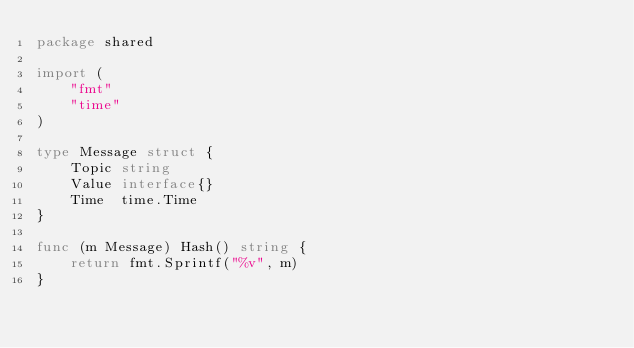<code> <loc_0><loc_0><loc_500><loc_500><_Go_>package shared

import (
	"fmt"
	"time"
)

type Message struct {
	Topic string
	Value interface{}
	Time  time.Time
}

func (m Message) Hash() string {
	return fmt.Sprintf("%v", m)
}
</code> 